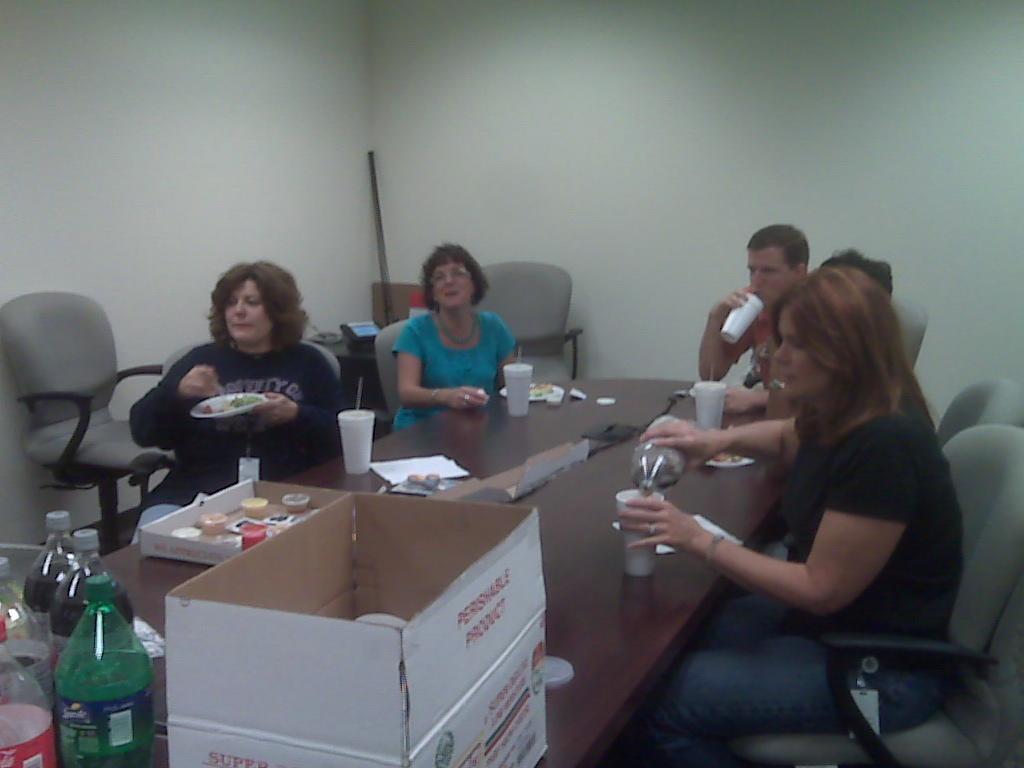In one or two sentences, can you explain what this image depicts? In this image I can see a group of people are sitting on a chair in front of a table. On the table I can see a box and other objects on it. 